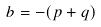Convert formula to latex. <formula><loc_0><loc_0><loc_500><loc_500>b = - ( p + q )</formula> 